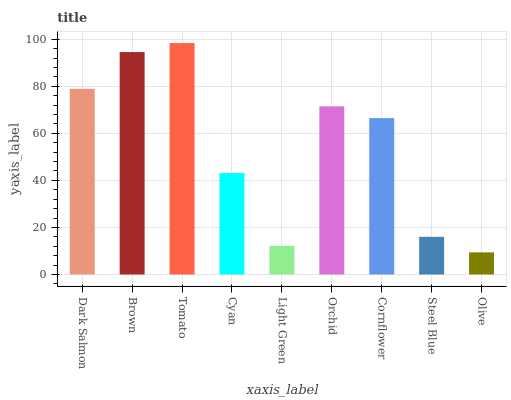Is Olive the minimum?
Answer yes or no. Yes. Is Tomato the maximum?
Answer yes or no. Yes. Is Brown the minimum?
Answer yes or no. No. Is Brown the maximum?
Answer yes or no. No. Is Brown greater than Dark Salmon?
Answer yes or no. Yes. Is Dark Salmon less than Brown?
Answer yes or no. Yes. Is Dark Salmon greater than Brown?
Answer yes or no. No. Is Brown less than Dark Salmon?
Answer yes or no. No. Is Cornflower the high median?
Answer yes or no. Yes. Is Cornflower the low median?
Answer yes or no. Yes. Is Brown the high median?
Answer yes or no. No. Is Brown the low median?
Answer yes or no. No. 